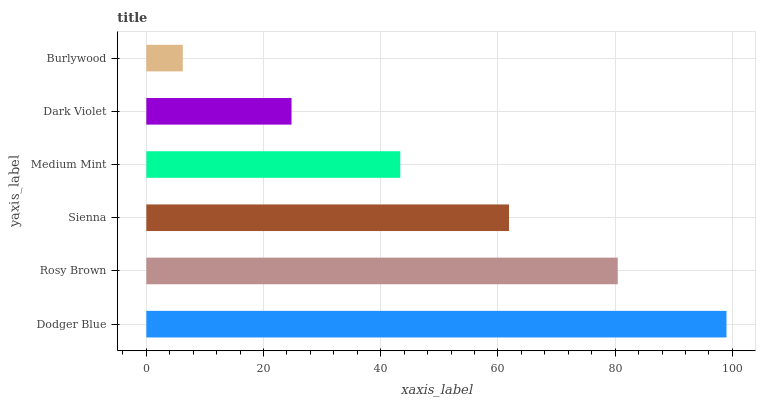Is Burlywood the minimum?
Answer yes or no. Yes. Is Dodger Blue the maximum?
Answer yes or no. Yes. Is Rosy Brown the minimum?
Answer yes or no. No. Is Rosy Brown the maximum?
Answer yes or no. No. Is Dodger Blue greater than Rosy Brown?
Answer yes or no. Yes. Is Rosy Brown less than Dodger Blue?
Answer yes or no. Yes. Is Rosy Brown greater than Dodger Blue?
Answer yes or no. No. Is Dodger Blue less than Rosy Brown?
Answer yes or no. No. Is Sienna the high median?
Answer yes or no. Yes. Is Medium Mint the low median?
Answer yes or no. Yes. Is Rosy Brown the high median?
Answer yes or no. No. Is Burlywood the low median?
Answer yes or no. No. 